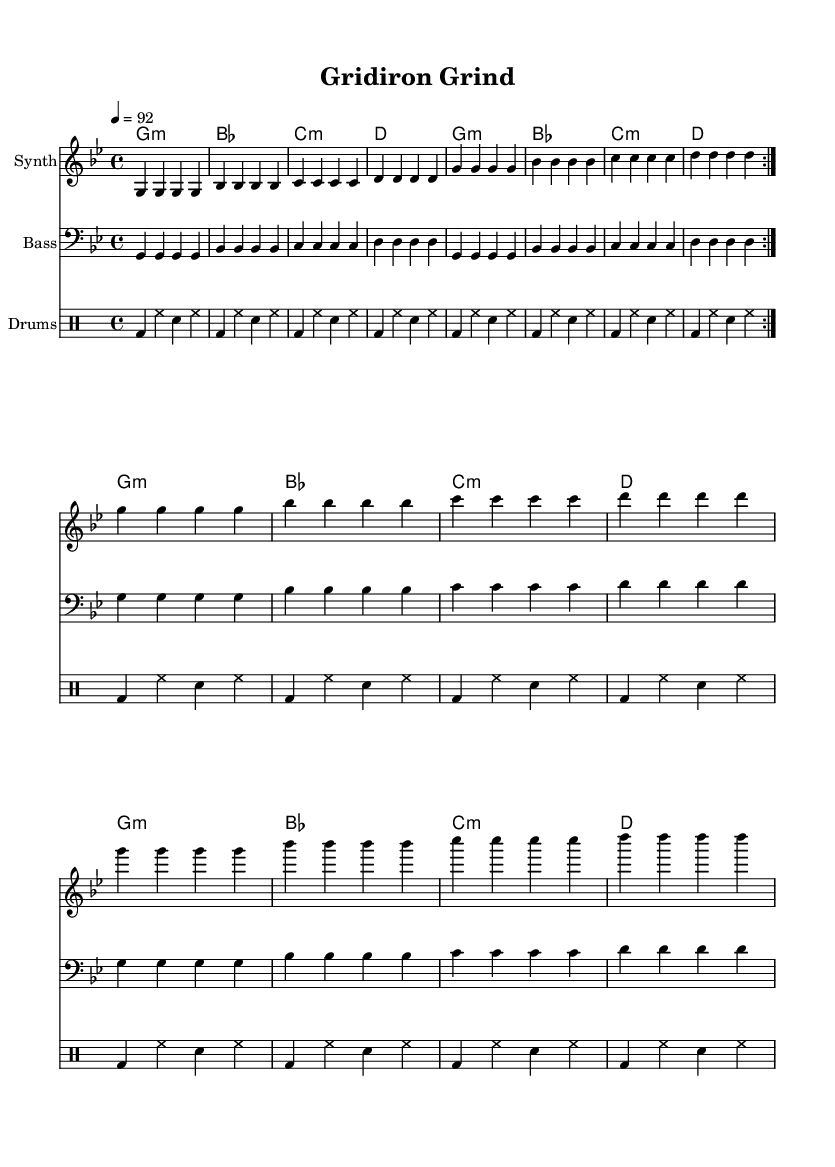What is the key signature of this music? The key signature is G minor, which has two flats (B flat and E flat).
Answer: G minor What is the time signature of this piece? The time signature is 4/4, indicating there are four beats in each measure.
Answer: 4/4 What is the tempo marking of this music? The tempo marking is 92 beats per minute, indicating the speed at which the piece should be played.
Answer: 92 How many measures are repeated in the melody? The melody contains a repeated section that is indicated to repeat twice in the first part, totaling 8 measures for that section.
Answer: 8 What type of instrument is indicated for the melody? The instrument indicated for the melody section is a Synth, which is often used in rap music for its electronic sound.
Answer: Synth Which chord is played for the first measure? The first measure features a G minor chord, setting the tonal foundation for the piece.
Answer: G minor What rhythmic pattern is primarily used in the drums? The primary rhythmic pattern in the drums includes a combination of bass drum, hi-hat, and snare beats, creating a steady pulse.
Answer: bass drum, hi-hat, snare 